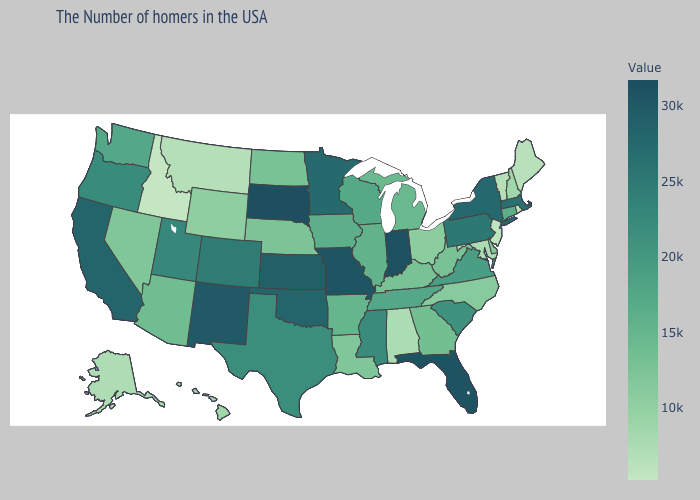Which states have the lowest value in the Northeast?
Be succinct. New Jersey. Does Idaho have the lowest value in the West?
Concise answer only. Yes. Does New York have the lowest value in the Northeast?
Quick response, please. No. Among the states that border Wisconsin , does Iowa have the lowest value?
Keep it brief. No. Which states have the lowest value in the West?
Be succinct. Idaho. Which states have the highest value in the USA?
Give a very brief answer. South Dakota. Among the states that border Maryland , does Delaware have the lowest value?
Keep it brief. Yes. Which states have the lowest value in the Northeast?
Keep it brief. New Jersey. Is the legend a continuous bar?
Answer briefly. Yes. 